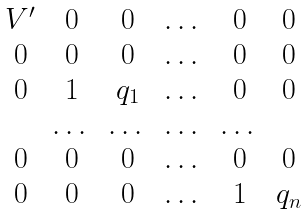<formula> <loc_0><loc_0><loc_500><loc_500>\begin{matrix} V ^ { \prime } & 0 & 0 & \dots & 0 & 0 \\ 0 & 0 & 0 & \dots & 0 & 0 \\ 0 & 1 & q _ { 1 } & \dots & 0 & 0 \\ & \dots & \dots & \dots & \dots & \\ 0 & 0 & 0 & \dots & 0 & 0 \\ 0 & 0 & 0 & \dots & 1 & q _ { n } \end{matrix}</formula> 